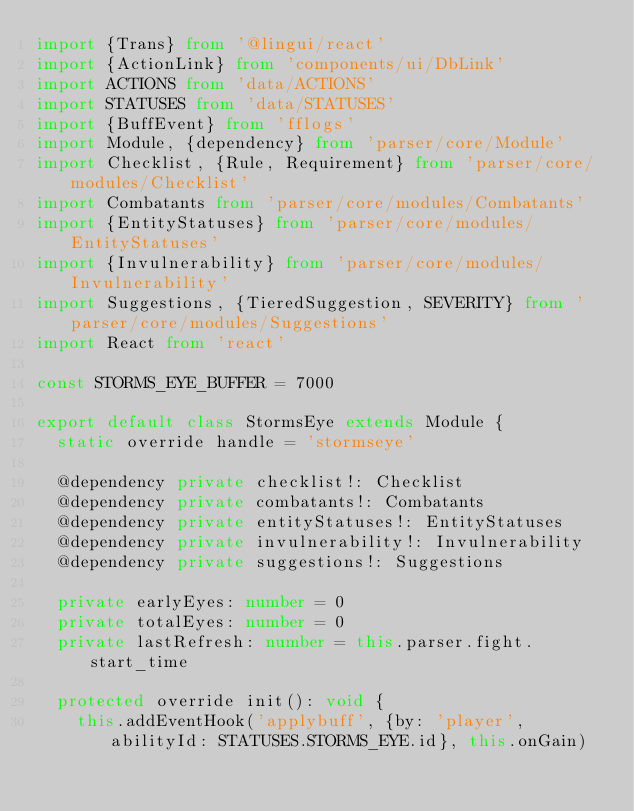Convert code to text. <code><loc_0><loc_0><loc_500><loc_500><_TypeScript_>import {Trans} from '@lingui/react'
import {ActionLink} from 'components/ui/DbLink'
import ACTIONS from 'data/ACTIONS'
import STATUSES from 'data/STATUSES'
import {BuffEvent} from 'fflogs'
import Module, {dependency} from 'parser/core/Module'
import Checklist, {Rule, Requirement} from 'parser/core/modules/Checklist'
import Combatants from 'parser/core/modules/Combatants'
import {EntityStatuses} from 'parser/core/modules/EntityStatuses'
import {Invulnerability} from 'parser/core/modules/Invulnerability'
import Suggestions, {TieredSuggestion, SEVERITY} from 'parser/core/modules/Suggestions'
import React from 'react'

const STORMS_EYE_BUFFER = 7000

export default class StormsEye extends Module {
	static override handle = 'stormseye'

	@dependency private checklist!: Checklist
	@dependency private combatants!: Combatants
	@dependency private entityStatuses!: EntityStatuses
	@dependency private invulnerability!: Invulnerability
	@dependency private suggestions!: Suggestions

	private earlyEyes: number = 0
	private totalEyes: number = 0
	private lastRefresh: number = this.parser.fight.start_time

	protected override init(): void {
		this.addEventHook('applybuff', {by: 'player', abilityId: STATUSES.STORMS_EYE.id}, this.onGain)</code> 